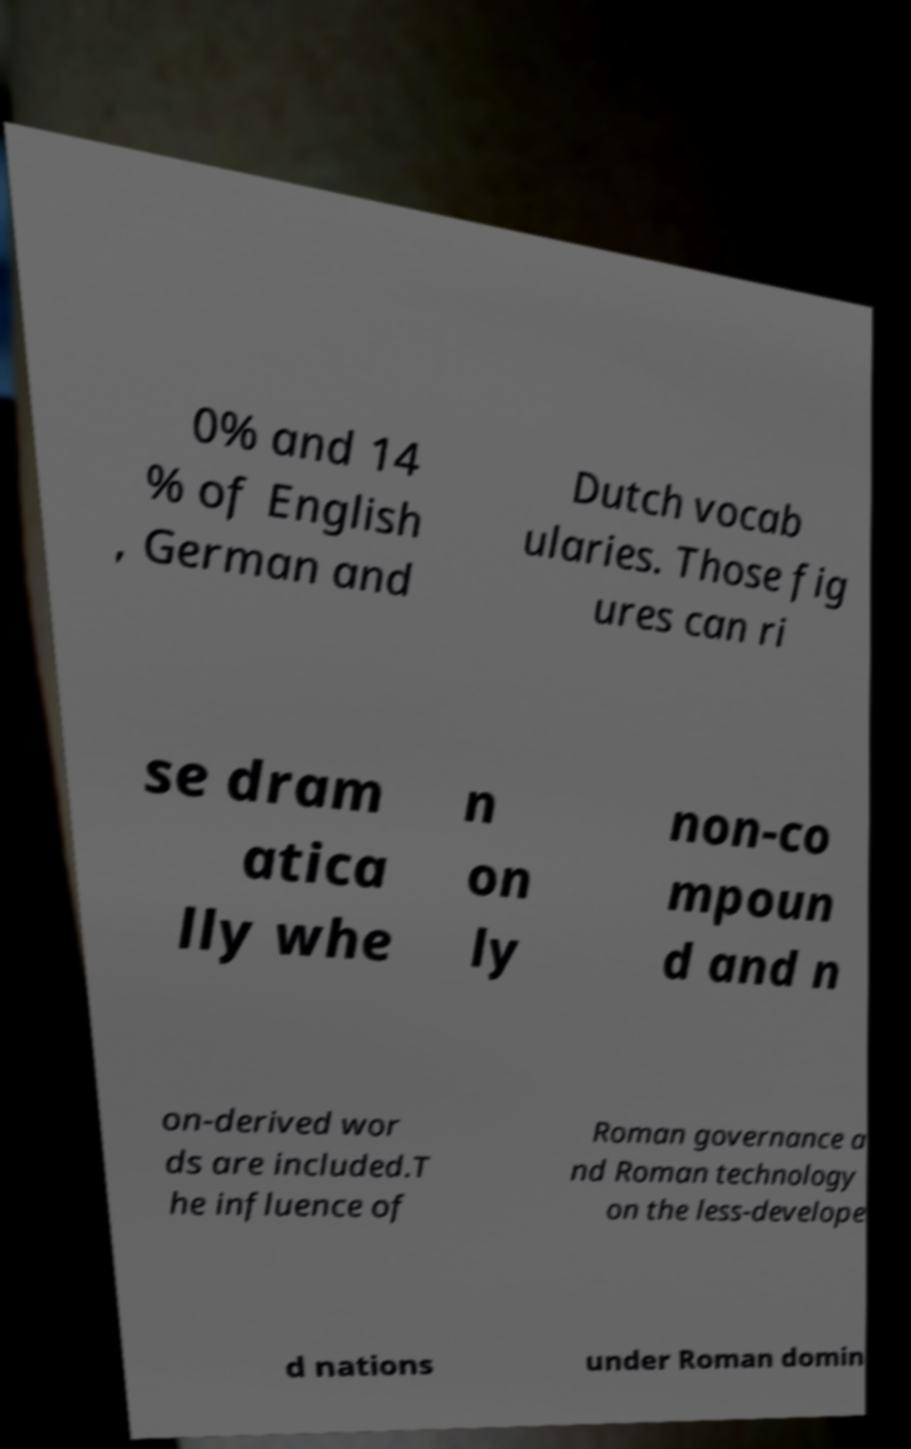There's text embedded in this image that I need extracted. Can you transcribe it verbatim? 0% and 14 % of English , German and Dutch vocab ularies. Those fig ures can ri se dram atica lly whe n on ly non-co mpoun d and n on-derived wor ds are included.T he influence of Roman governance a nd Roman technology on the less-develope d nations under Roman domin 